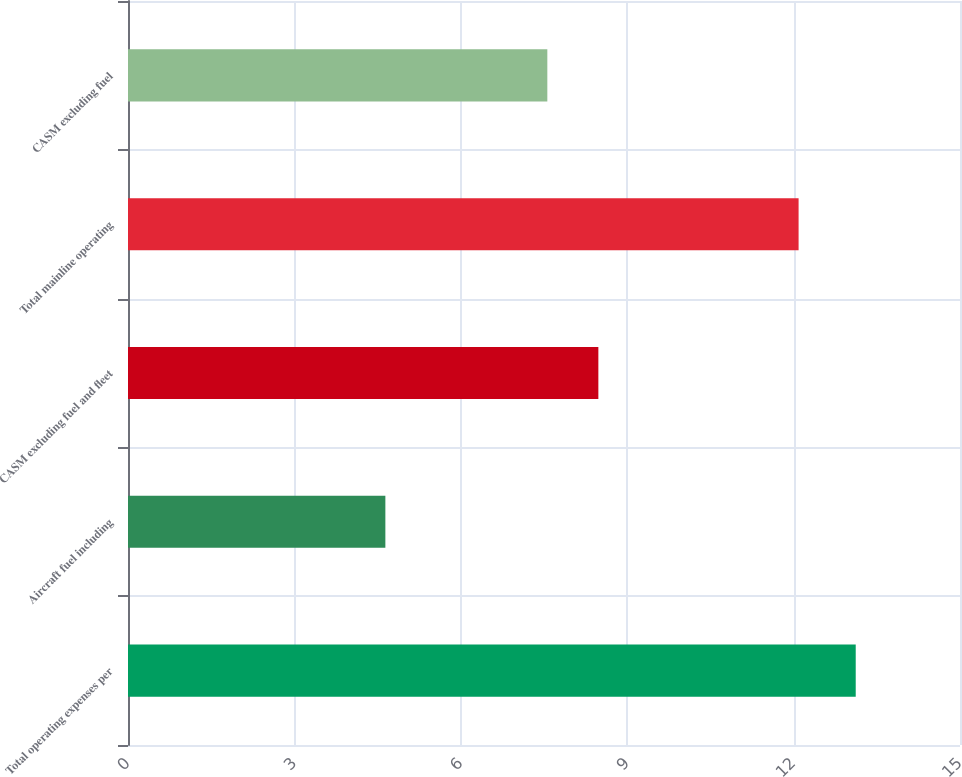Convert chart. <chart><loc_0><loc_0><loc_500><loc_500><bar_chart><fcel>Total operating expenses per<fcel>Aircraft fuel including<fcel>CASM excluding fuel and fleet<fcel>Total mainline operating<fcel>CASM excluding fuel<nl><fcel>13.12<fcel>4.64<fcel>8.48<fcel>12.09<fcel>7.56<nl></chart> 